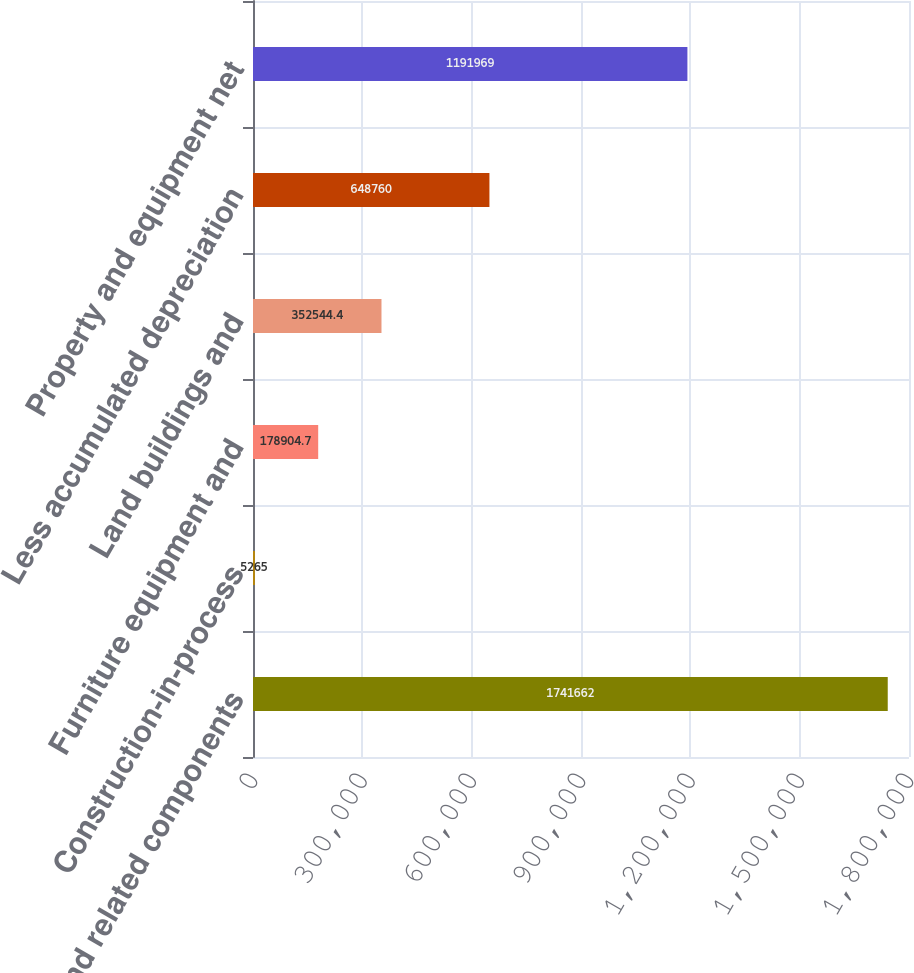Convert chart to OTSL. <chart><loc_0><loc_0><loc_500><loc_500><bar_chart><fcel>Towers and related components<fcel>Construction-in-process<fcel>Furniture equipment and<fcel>Land buildings and<fcel>Less accumulated depreciation<fcel>Property and equipment net<nl><fcel>1.74166e+06<fcel>5265<fcel>178905<fcel>352544<fcel>648760<fcel>1.19197e+06<nl></chart> 